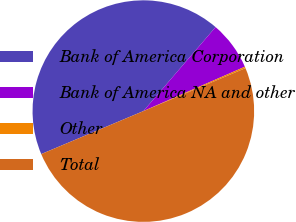Convert chart to OTSL. <chart><loc_0><loc_0><loc_500><loc_500><pie_chart><fcel>Bank of America Corporation<fcel>Bank of America NA and other<fcel>Other<fcel>Total<nl><fcel>42.64%<fcel>7.14%<fcel>0.22%<fcel>50.0%<nl></chart> 